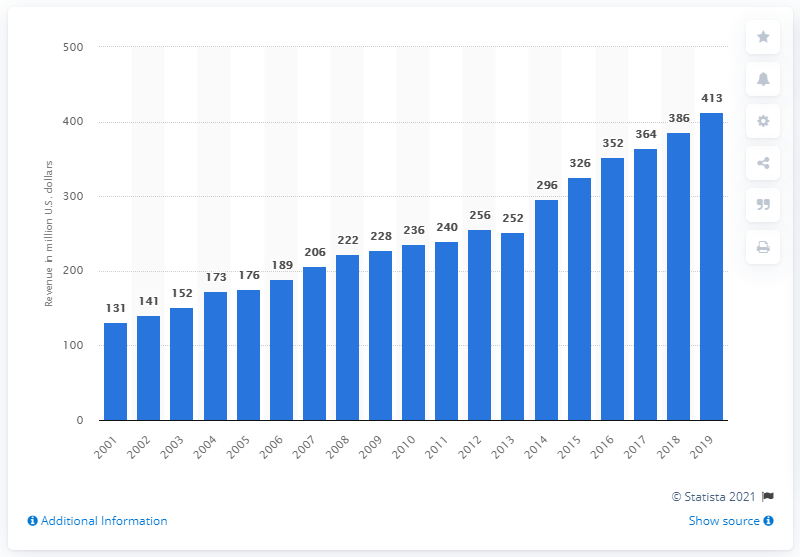Mention a couple of crucial points in this snapshot. The revenue of the Buffalo Bills in 2019 was $413 million. The Buffalo Bills first made money in the year 2001. 